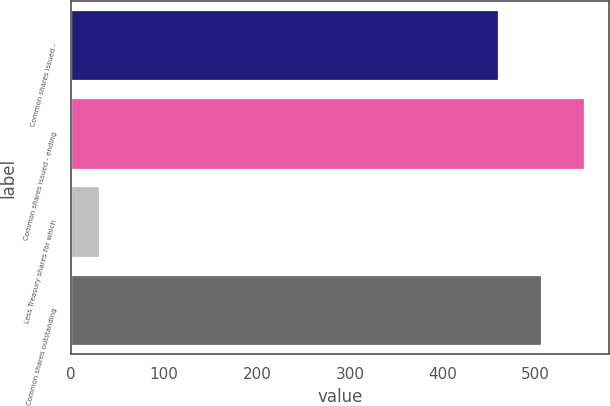Convert chart. <chart><loc_0><loc_0><loc_500><loc_500><bar_chart><fcel>Common shares issued -<fcel>Common shares issued - ending<fcel>Less Treasury shares for which<fcel>Common shares outstanding<nl><fcel>459.5<fcel>551.52<fcel>30.3<fcel>505.51<nl></chart> 